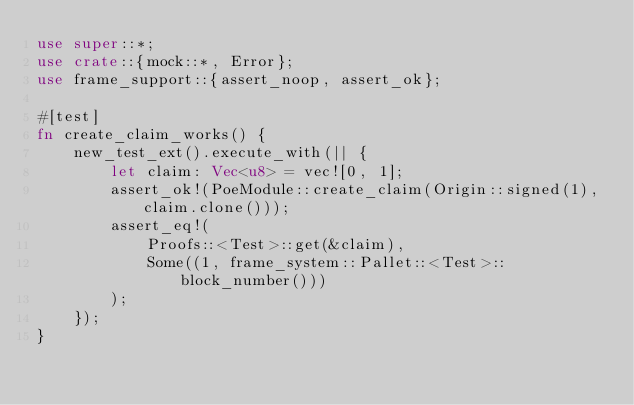<code> <loc_0><loc_0><loc_500><loc_500><_Rust_>use super::*;
use crate::{mock::*, Error};
use frame_support::{assert_noop, assert_ok};

#[test]
fn create_claim_works() {
	new_test_ext().execute_with(|| {
		let claim: Vec<u8> = vec![0, 1];
		assert_ok!(PoeModule::create_claim(Origin::signed(1), claim.clone()));
		assert_eq!(
			Proofs::<Test>::get(&claim),
			Some((1, frame_system::Pallet::<Test>::block_number()))
		);
	});
}
</code> 